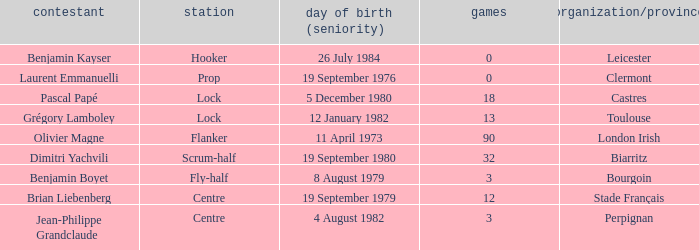What is the position of Perpignan? Centre. 